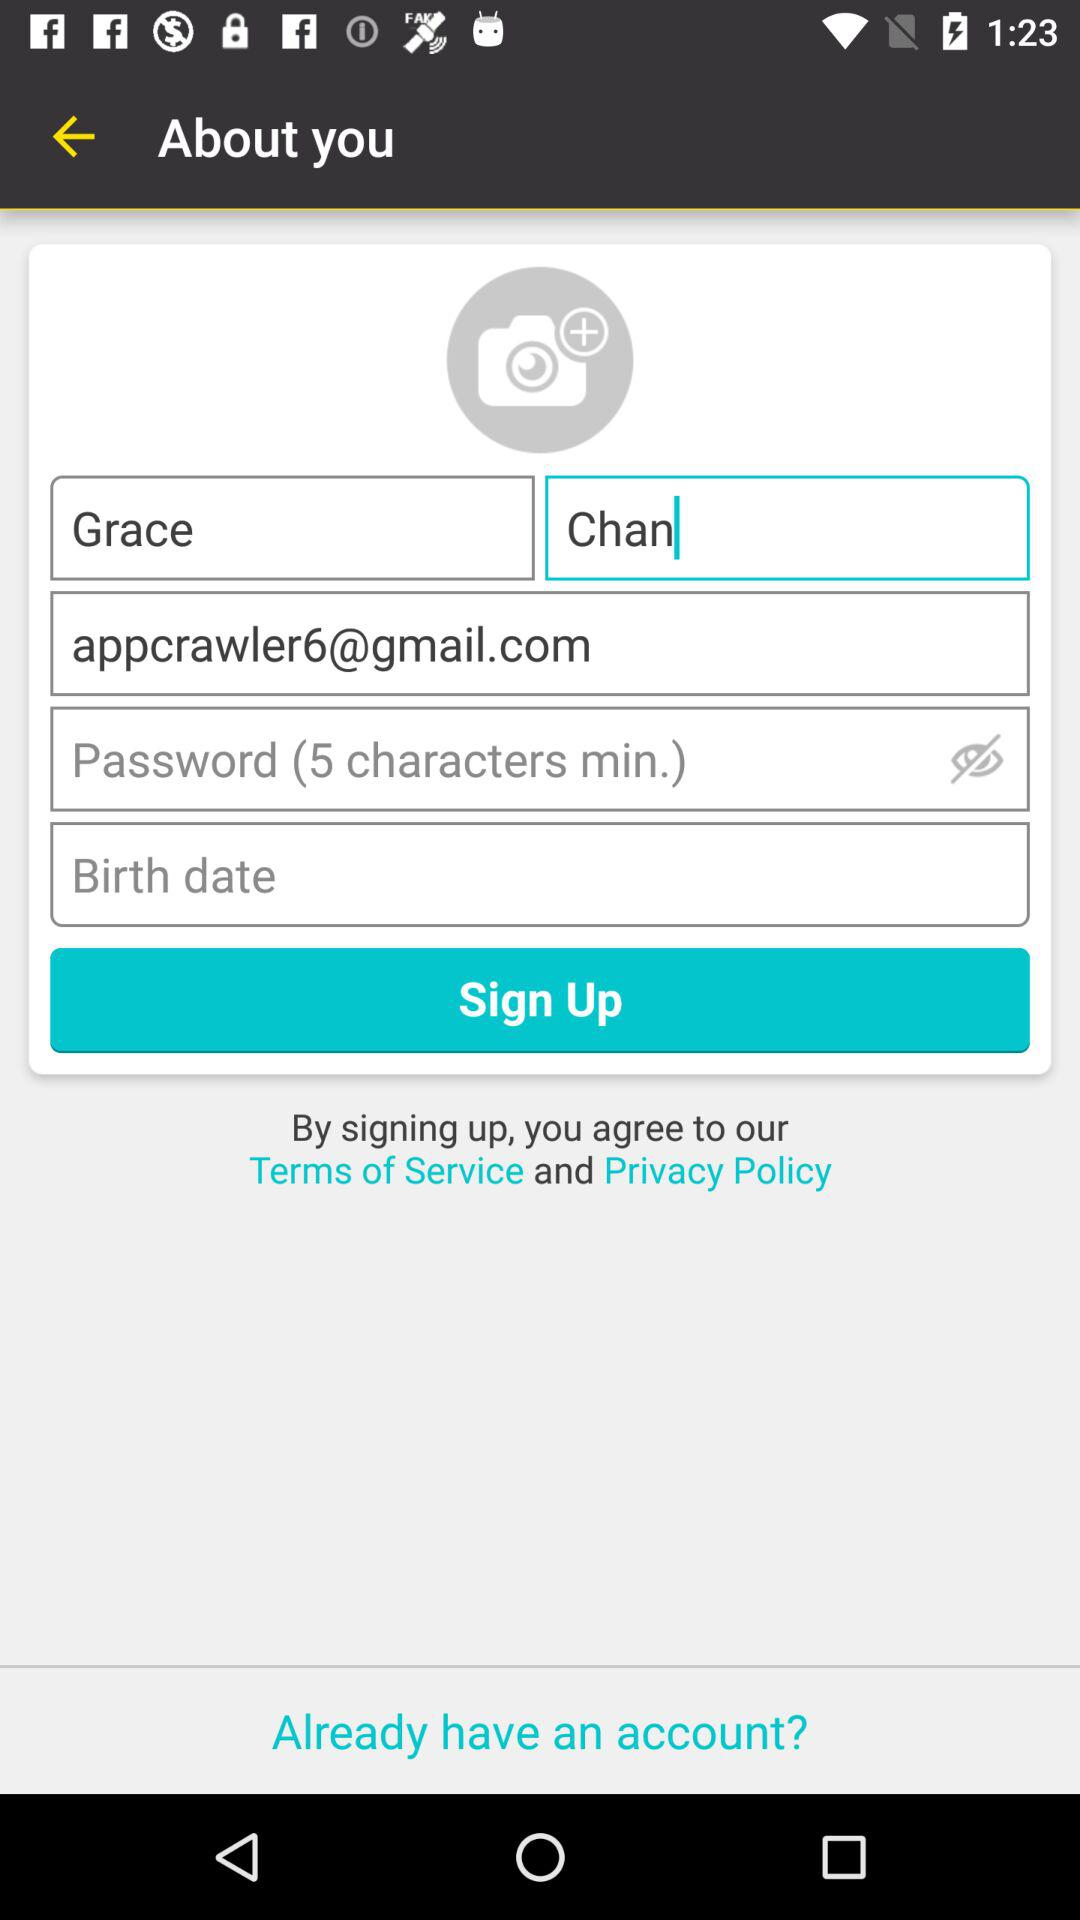How many minimum characters are required in a password? The required minimum characters in a password are 5. 